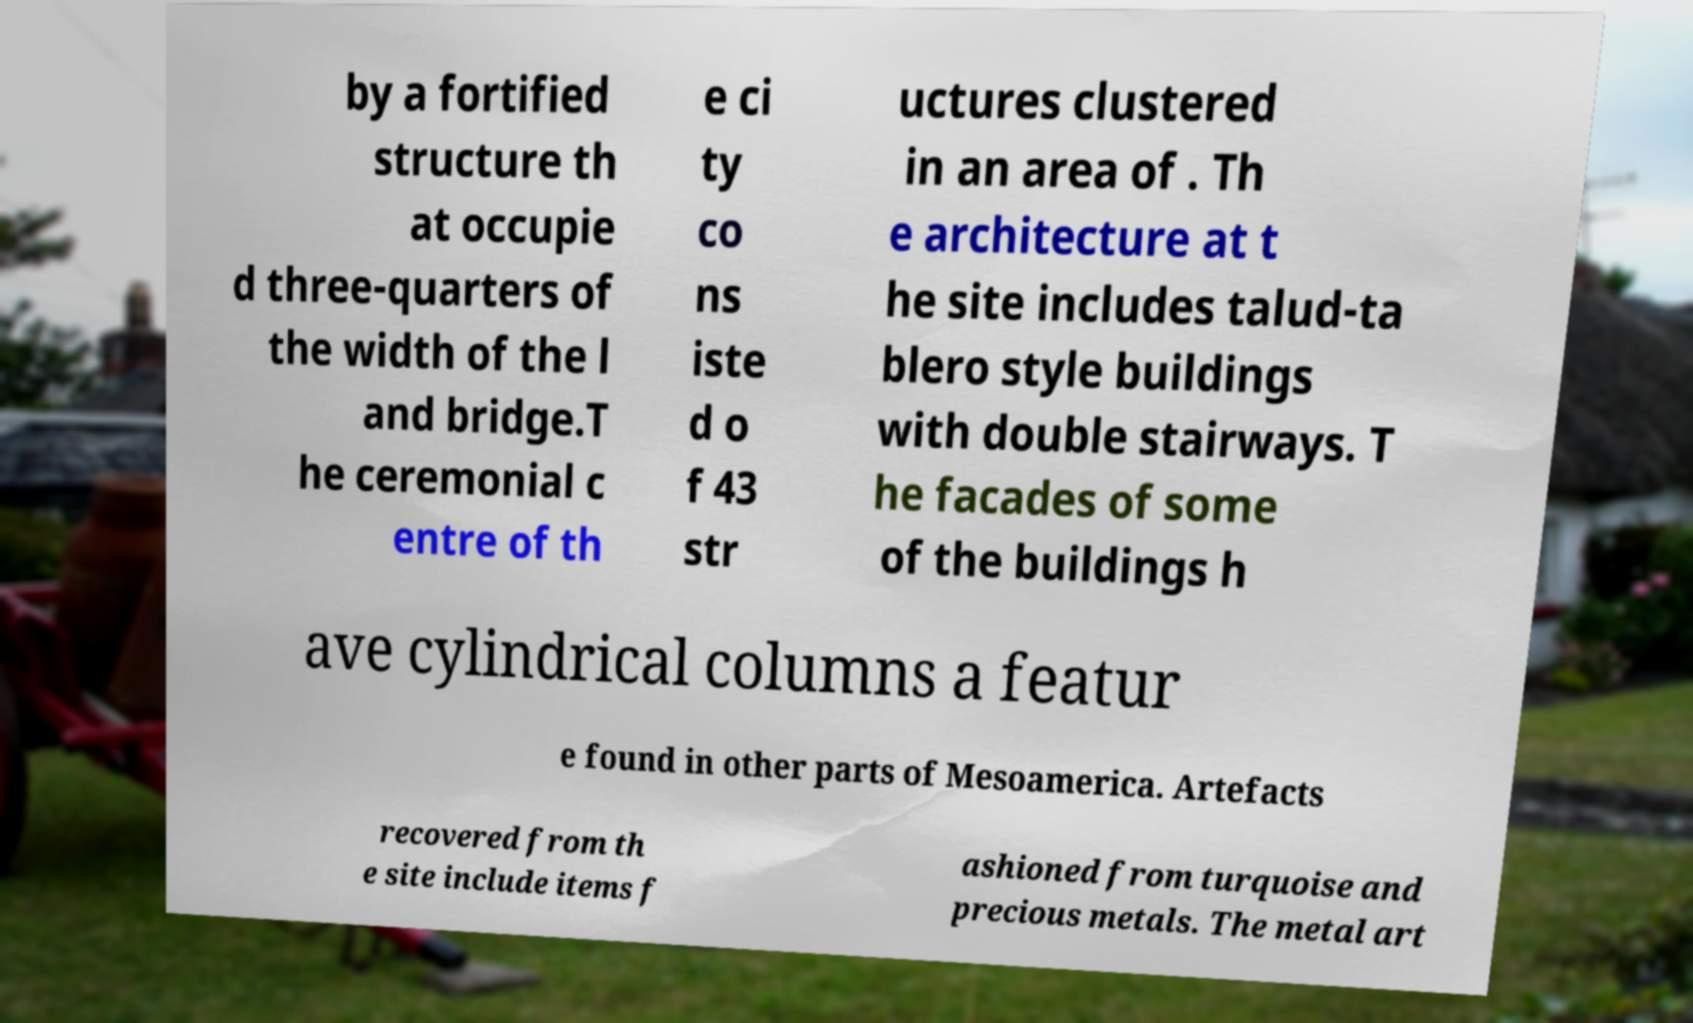Could you assist in decoding the text presented in this image and type it out clearly? by a fortified structure th at occupie d three-quarters of the width of the l and bridge.T he ceremonial c entre of th e ci ty co ns iste d o f 43 str uctures clustered in an area of . Th e architecture at t he site includes talud-ta blero style buildings with double stairways. T he facades of some of the buildings h ave cylindrical columns a featur e found in other parts of Mesoamerica. Artefacts recovered from th e site include items f ashioned from turquoise and precious metals. The metal art 